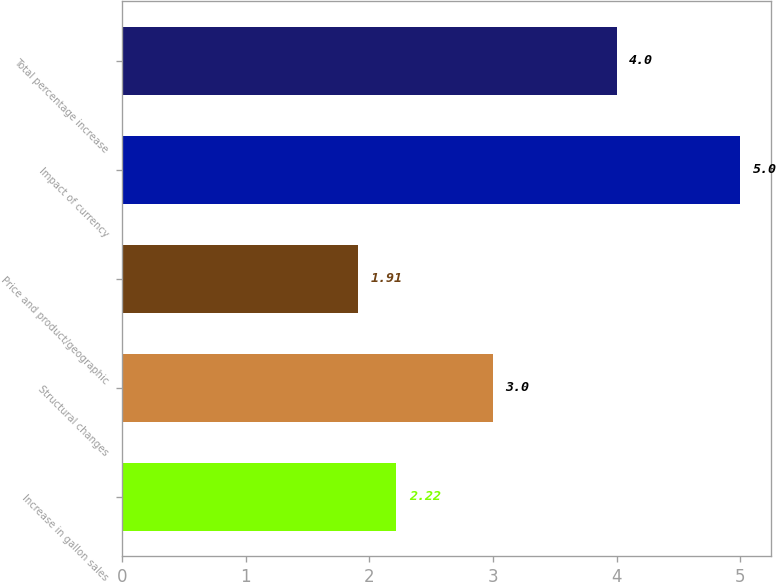<chart> <loc_0><loc_0><loc_500><loc_500><bar_chart><fcel>Increase in gallon sales<fcel>Structural changes<fcel>Price and product/geographic<fcel>Impact of currency<fcel>Total percentage increase<nl><fcel>2.22<fcel>3<fcel>1.91<fcel>5<fcel>4<nl></chart> 